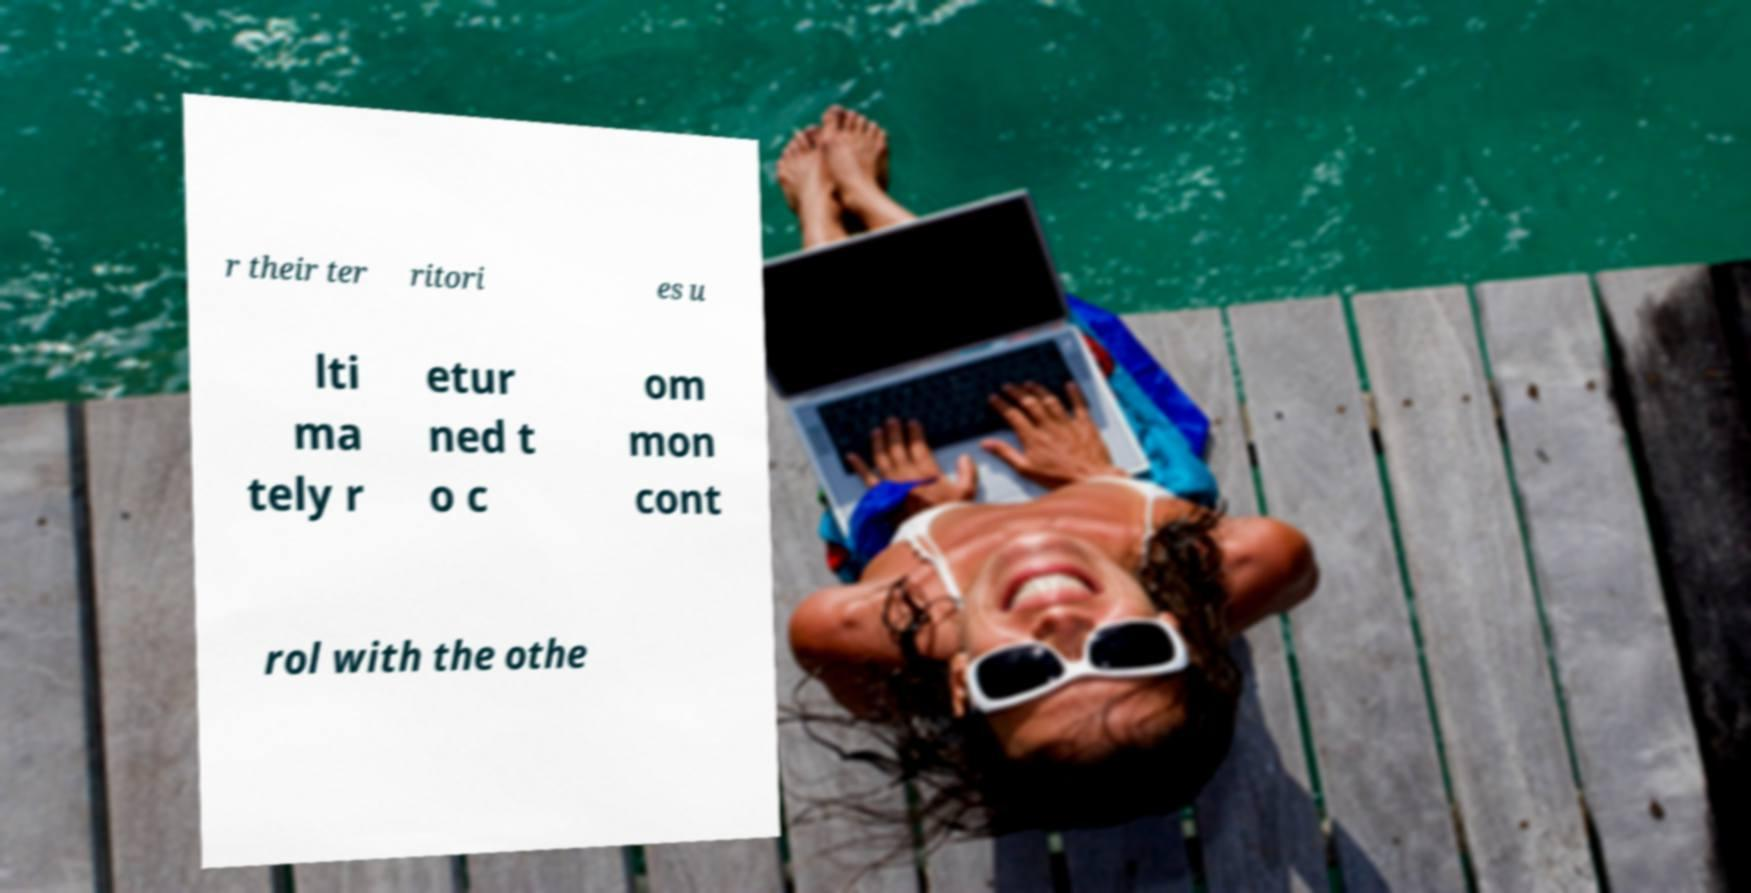Could you assist in decoding the text presented in this image and type it out clearly? r their ter ritori es u lti ma tely r etur ned t o c om mon cont rol with the othe 